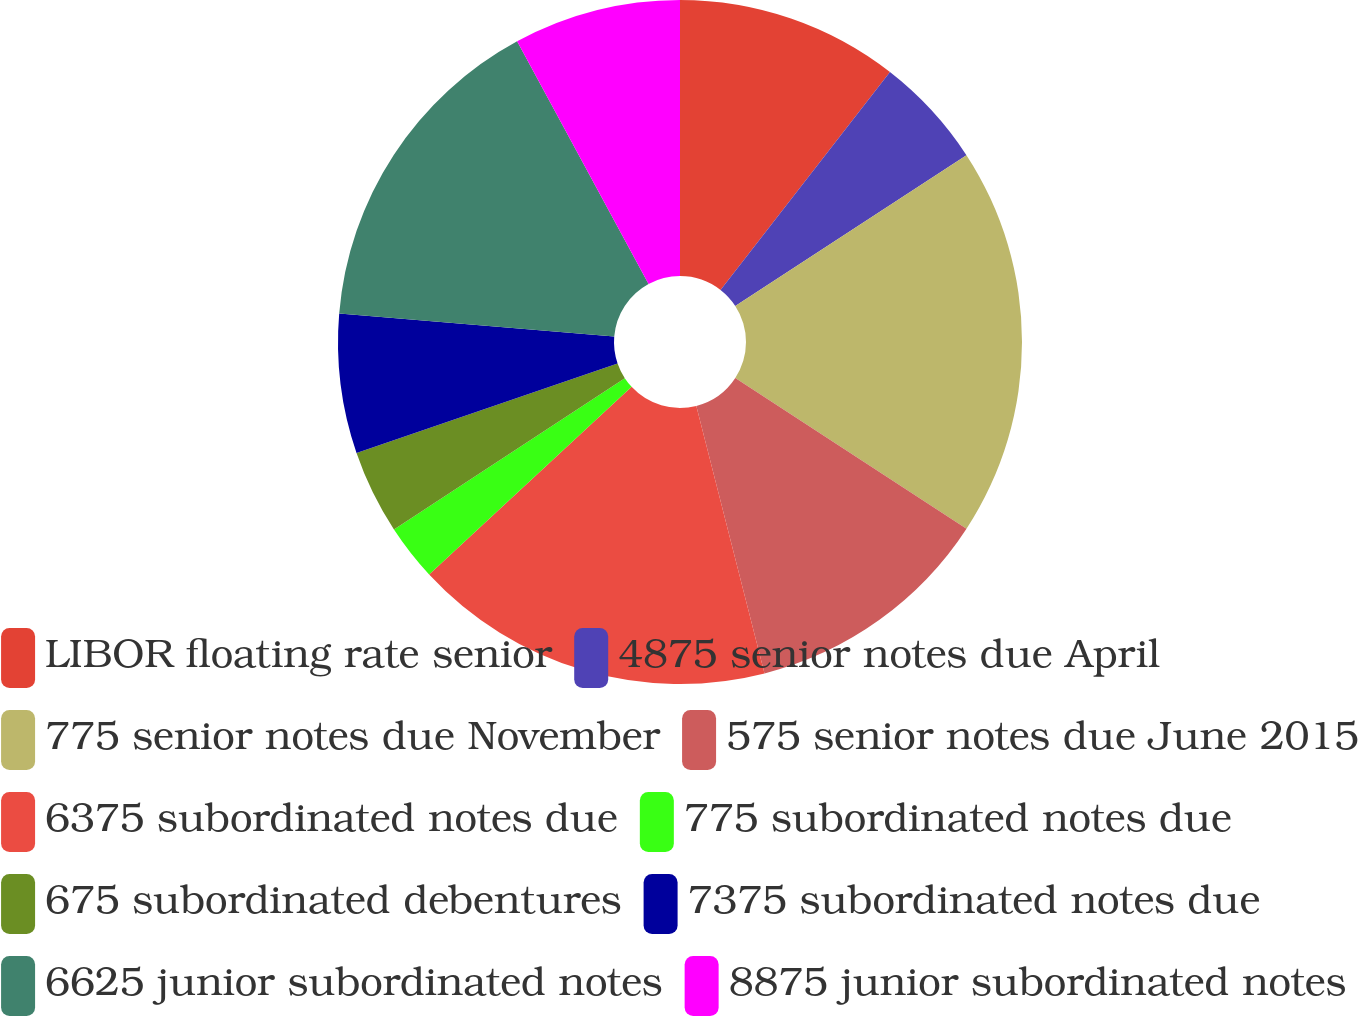Convert chart. <chart><loc_0><loc_0><loc_500><loc_500><pie_chart><fcel>LIBOR floating rate senior<fcel>4875 senior notes due April<fcel>775 senior notes due November<fcel>575 senior notes due June 2015<fcel>6375 subordinated notes due<fcel>775 subordinated notes due<fcel>675 subordinated debentures<fcel>7375 subordinated notes due<fcel>6625 junior subordinated notes<fcel>8875 junior subordinated notes<nl><fcel>10.52%<fcel>5.28%<fcel>18.39%<fcel>11.83%<fcel>17.08%<fcel>2.66%<fcel>3.97%<fcel>6.59%<fcel>15.77%<fcel>7.9%<nl></chart> 